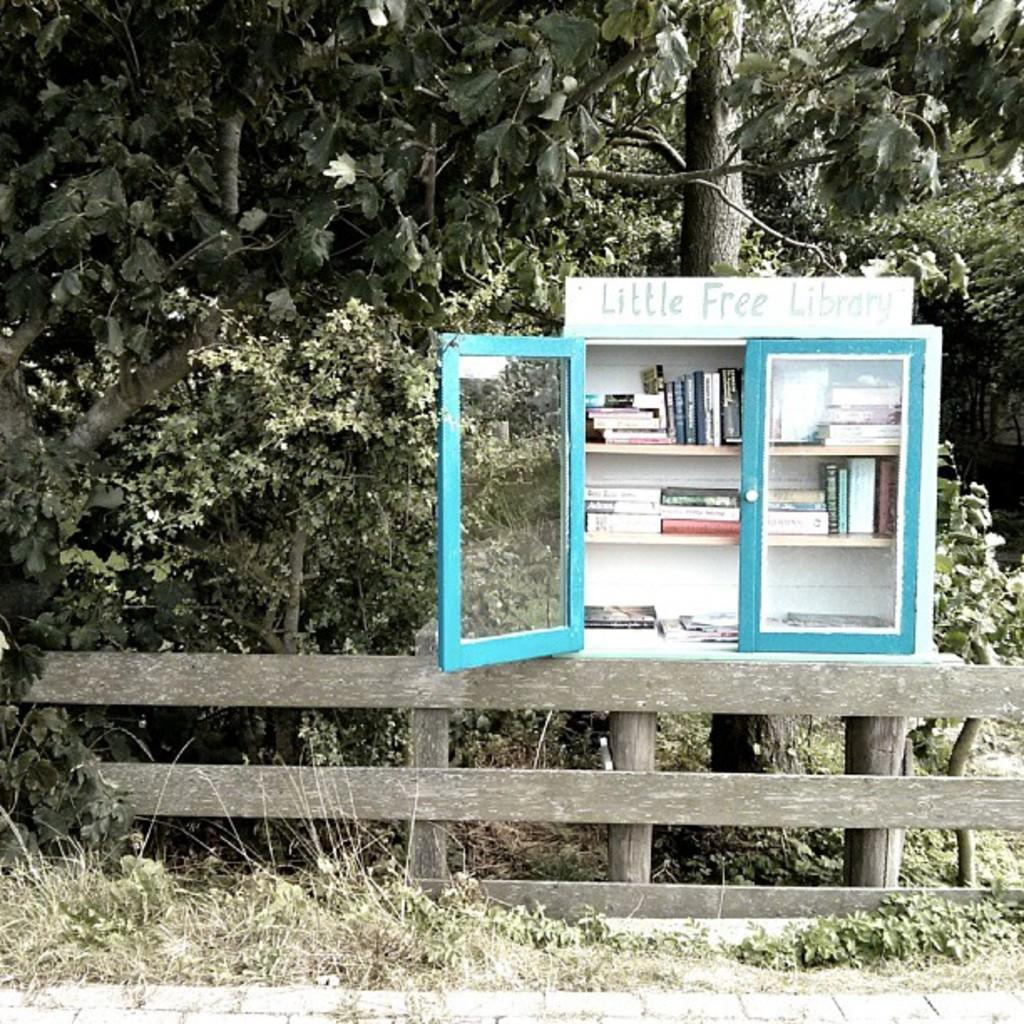<image>
Describe the image concisely. A white and tell blue cabinet is a Little Free Library. 